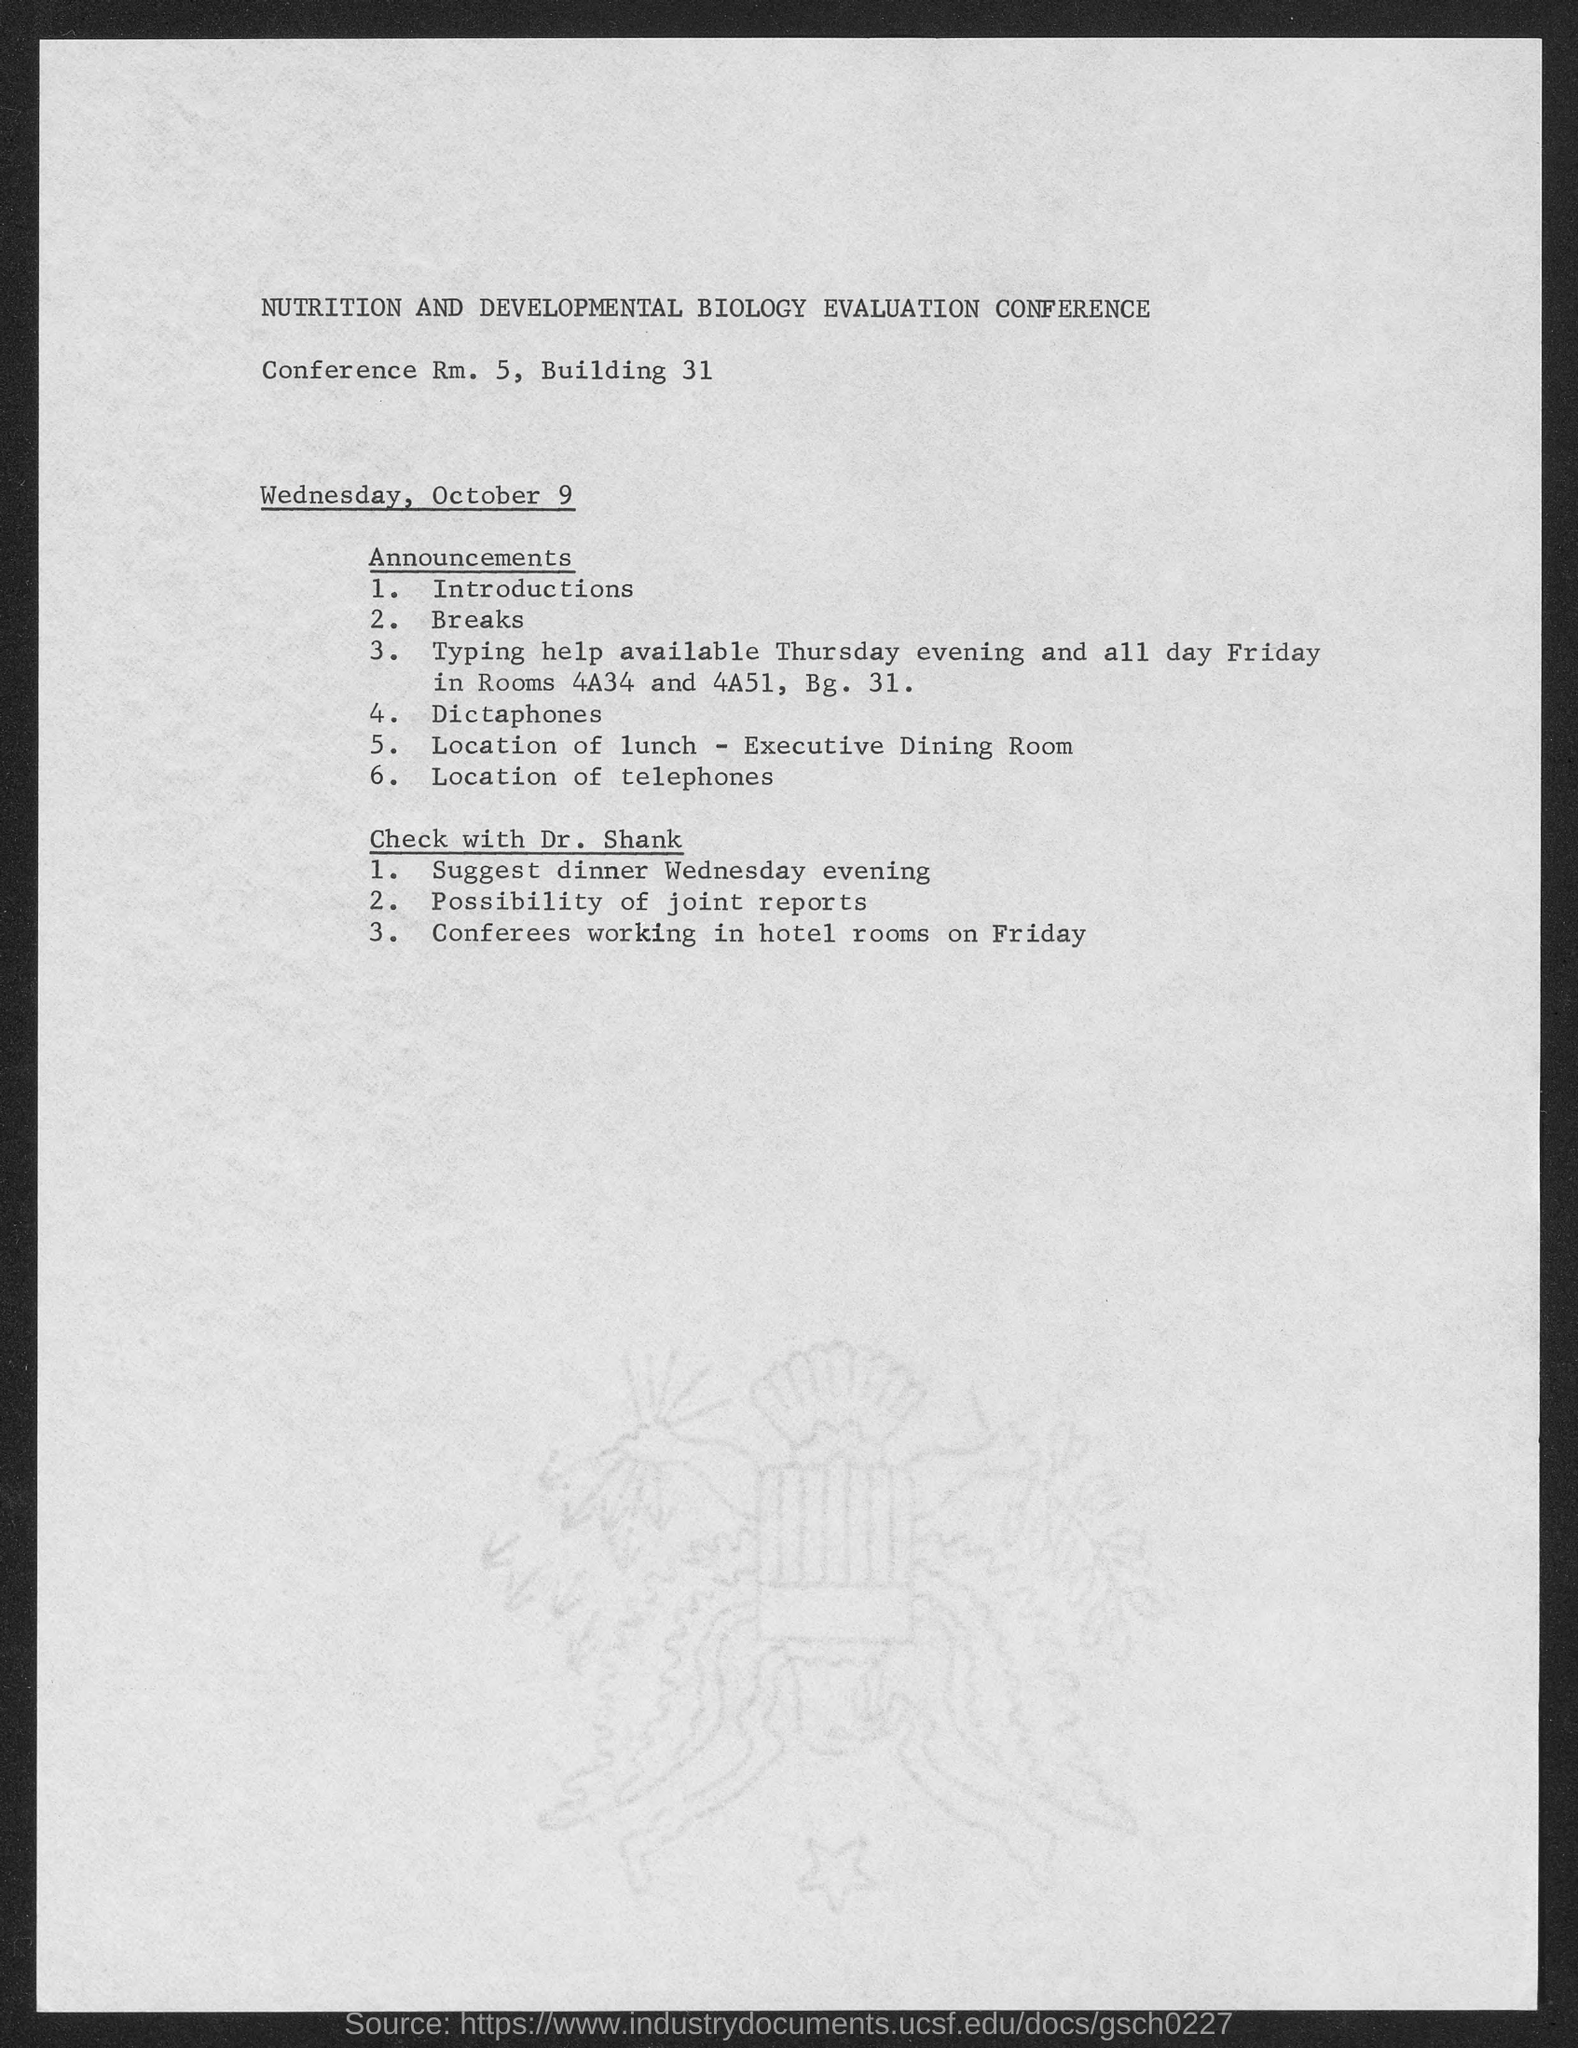Where is the location of Conference mentioned here?
Provide a succinct answer. Conference Rm. 5, Building 31. On which date the Conference was started?
Ensure brevity in your answer.  Wednesday, October 9. 